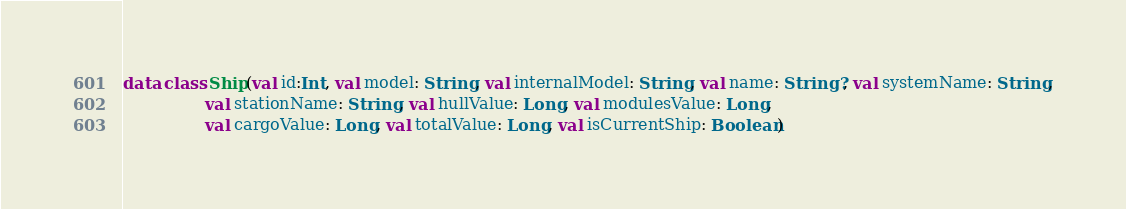<code> <loc_0><loc_0><loc_500><loc_500><_Kotlin_>data class Ship(val id:Int, val model: String, val internalModel: String, val name: String?, val systemName: String,
                val stationName: String, val hullValue: Long, val modulesValue: Long,
                val cargoValue: Long, val totalValue: Long, val isCurrentShip: Boolean)</code> 